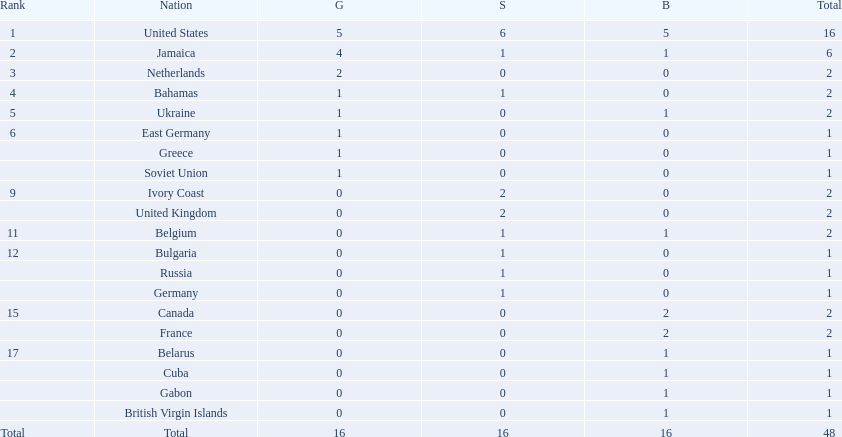Which countries participated? United States, Jamaica, Netherlands, Bahamas, Ukraine, East Germany, Greece, Soviet Union, Ivory Coast, United Kingdom, Belgium, Bulgaria, Russia, Germany, Canada, France, Belarus, Cuba, Gabon, British Virgin Islands. How many gold medals were won by each? 5, 4, 2, 1, 1, 1, 1, 1, 0, 0, 0, 0, 0, 0, 0, 0, 0, 0, 0, 0. And which country won the most? United States. 